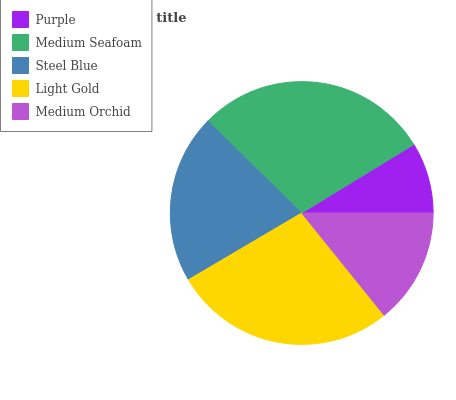Is Purple the minimum?
Answer yes or no. Yes. Is Medium Seafoam the maximum?
Answer yes or no. Yes. Is Steel Blue the minimum?
Answer yes or no. No. Is Steel Blue the maximum?
Answer yes or no. No. Is Medium Seafoam greater than Steel Blue?
Answer yes or no. Yes. Is Steel Blue less than Medium Seafoam?
Answer yes or no. Yes. Is Steel Blue greater than Medium Seafoam?
Answer yes or no. No. Is Medium Seafoam less than Steel Blue?
Answer yes or no. No. Is Steel Blue the high median?
Answer yes or no. Yes. Is Steel Blue the low median?
Answer yes or no. Yes. Is Medium Orchid the high median?
Answer yes or no. No. Is Purple the low median?
Answer yes or no. No. 